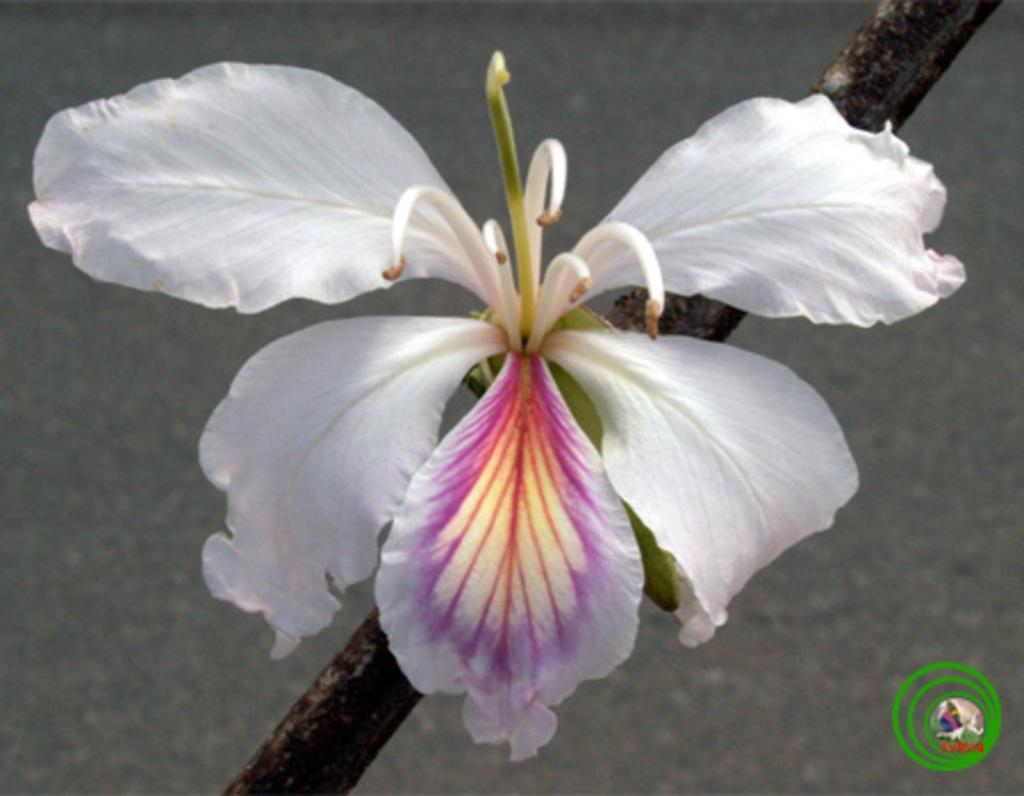What is the main subject of the image? There is a flower in the center of the image. Can you describe the flower in more detail? The flower has a stem. What type of flame can be seen burning near the flower in the image? There is no flame present in the image; it only features a flower with a stem. 